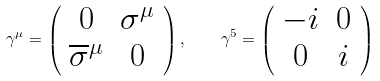<formula> <loc_0><loc_0><loc_500><loc_500>\gamma ^ { \mu } = \left ( \begin{array} { c c } 0 & \sigma ^ { \mu } \\ \overline { \sigma } ^ { \mu } & 0 \end{array} \right ) , \quad \gamma ^ { 5 } = \left ( \begin{array} { c c } - i & 0 \\ 0 & i \end{array} \right )</formula> 